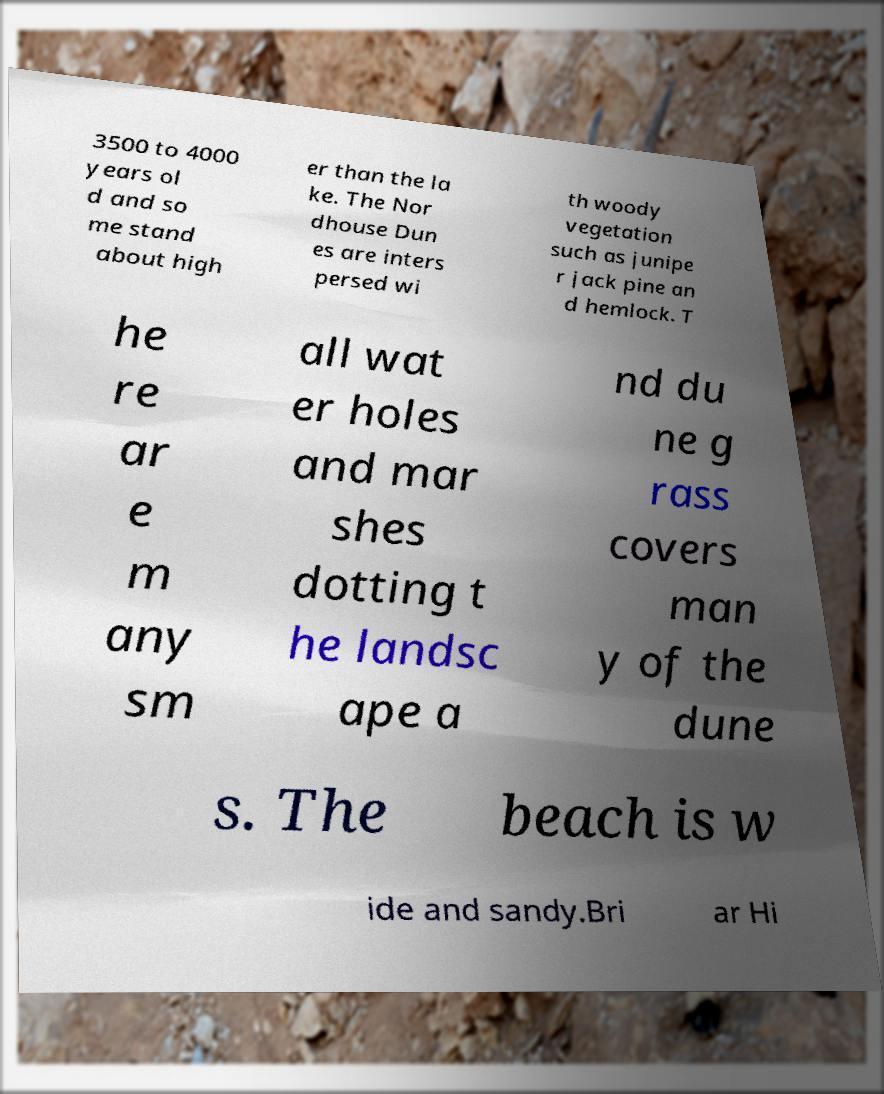Please read and relay the text visible in this image. What does it say? 3500 to 4000 years ol d and so me stand about high er than the la ke. The Nor dhouse Dun es are inters persed wi th woody vegetation such as junipe r jack pine an d hemlock. T he re ar e m any sm all wat er holes and mar shes dotting t he landsc ape a nd du ne g rass covers man y of the dune s. The beach is w ide and sandy.Bri ar Hi 